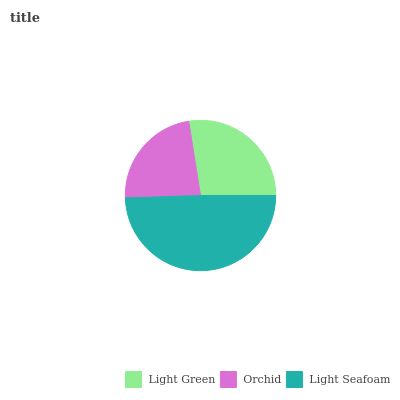Is Orchid the minimum?
Answer yes or no. Yes. Is Light Seafoam the maximum?
Answer yes or no. Yes. Is Light Seafoam the minimum?
Answer yes or no. No. Is Orchid the maximum?
Answer yes or no. No. Is Light Seafoam greater than Orchid?
Answer yes or no. Yes. Is Orchid less than Light Seafoam?
Answer yes or no. Yes. Is Orchid greater than Light Seafoam?
Answer yes or no. No. Is Light Seafoam less than Orchid?
Answer yes or no. No. Is Light Green the high median?
Answer yes or no. Yes. Is Light Green the low median?
Answer yes or no. Yes. Is Light Seafoam the high median?
Answer yes or no. No. Is Light Seafoam the low median?
Answer yes or no. No. 